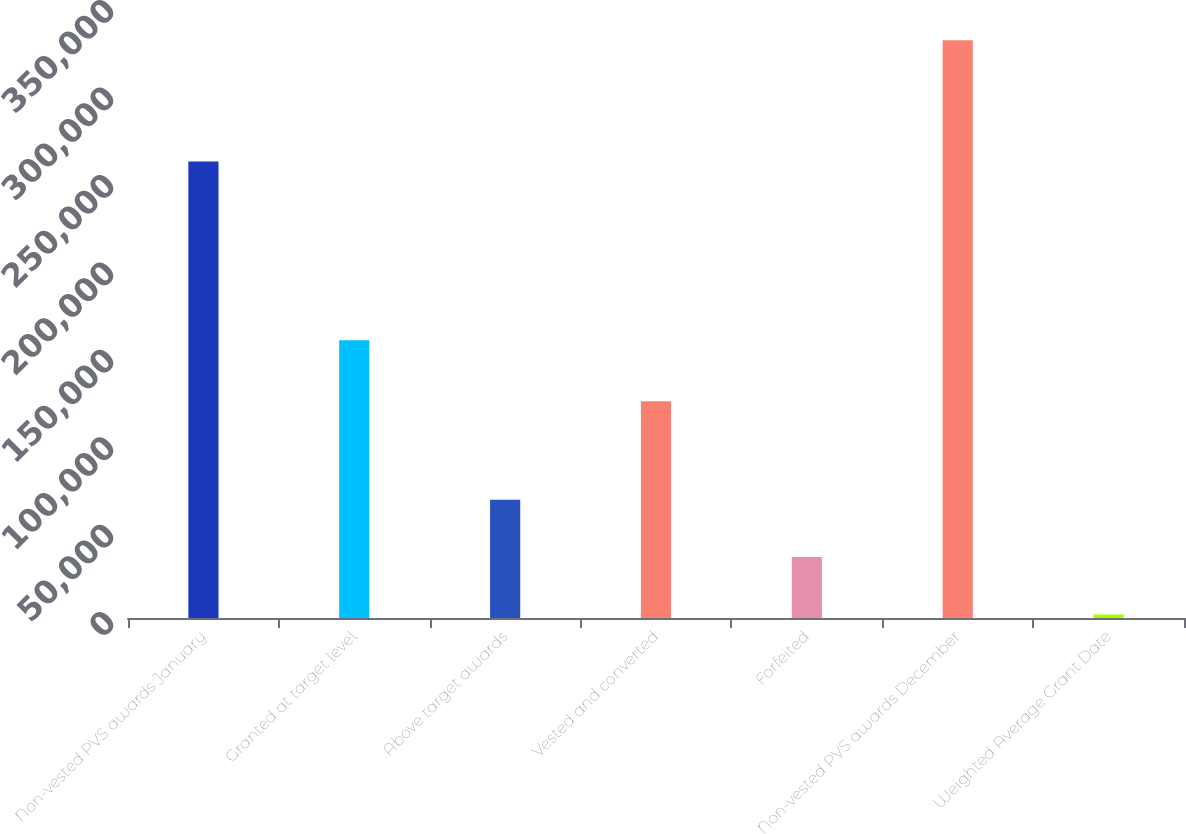<chart> <loc_0><loc_0><loc_500><loc_500><bar_chart><fcel>Non-vested PVS awards January<fcel>Granted at target level<fcel>Above target awards<fcel>Vested and converted<fcel>Forfeited<fcel>Non-vested PVS awards December<fcel>Weighted Average Grant Date<nl><fcel>261131<fcel>158795<fcel>67698<fcel>123891<fcel>34853<fcel>330458<fcel>2008<nl></chart> 